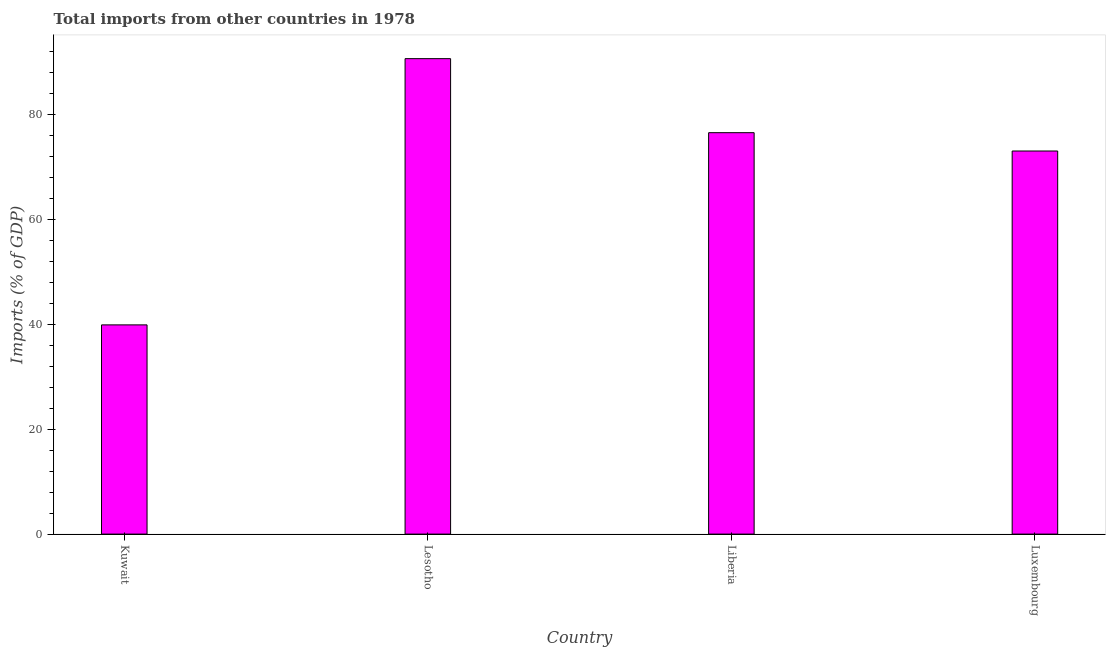What is the title of the graph?
Offer a very short reply. Total imports from other countries in 1978. What is the label or title of the X-axis?
Provide a short and direct response. Country. What is the label or title of the Y-axis?
Your answer should be very brief. Imports (% of GDP). What is the total imports in Lesotho?
Provide a short and direct response. 90.6. Across all countries, what is the maximum total imports?
Provide a succinct answer. 90.6. Across all countries, what is the minimum total imports?
Provide a succinct answer. 39.87. In which country was the total imports maximum?
Ensure brevity in your answer.  Lesotho. In which country was the total imports minimum?
Keep it short and to the point. Kuwait. What is the sum of the total imports?
Your answer should be compact. 279.94. What is the difference between the total imports in Liberia and Luxembourg?
Your answer should be compact. 3.49. What is the average total imports per country?
Make the answer very short. 69.99. What is the median total imports?
Ensure brevity in your answer.  74.74. What is the ratio of the total imports in Kuwait to that in Luxembourg?
Give a very brief answer. 0.55. Is the difference between the total imports in Kuwait and Lesotho greater than the difference between any two countries?
Your response must be concise. Yes. What is the difference between the highest and the second highest total imports?
Offer a very short reply. 14.11. What is the difference between the highest and the lowest total imports?
Your response must be concise. 50.73. Are the values on the major ticks of Y-axis written in scientific E-notation?
Offer a terse response. No. What is the Imports (% of GDP) of Kuwait?
Ensure brevity in your answer.  39.87. What is the Imports (% of GDP) of Lesotho?
Your answer should be compact. 90.6. What is the Imports (% of GDP) in Liberia?
Offer a very short reply. 76.49. What is the Imports (% of GDP) in Luxembourg?
Offer a terse response. 73. What is the difference between the Imports (% of GDP) in Kuwait and Lesotho?
Offer a very short reply. -50.73. What is the difference between the Imports (% of GDP) in Kuwait and Liberia?
Your response must be concise. -36.62. What is the difference between the Imports (% of GDP) in Kuwait and Luxembourg?
Make the answer very short. -33.13. What is the difference between the Imports (% of GDP) in Lesotho and Liberia?
Keep it short and to the point. 14.11. What is the difference between the Imports (% of GDP) in Lesotho and Luxembourg?
Your answer should be compact. 17.6. What is the difference between the Imports (% of GDP) in Liberia and Luxembourg?
Make the answer very short. 3.49. What is the ratio of the Imports (% of GDP) in Kuwait to that in Lesotho?
Your answer should be very brief. 0.44. What is the ratio of the Imports (% of GDP) in Kuwait to that in Liberia?
Provide a succinct answer. 0.52. What is the ratio of the Imports (% of GDP) in Kuwait to that in Luxembourg?
Your answer should be compact. 0.55. What is the ratio of the Imports (% of GDP) in Lesotho to that in Liberia?
Offer a very short reply. 1.18. What is the ratio of the Imports (% of GDP) in Lesotho to that in Luxembourg?
Provide a succinct answer. 1.24. What is the ratio of the Imports (% of GDP) in Liberia to that in Luxembourg?
Your response must be concise. 1.05. 